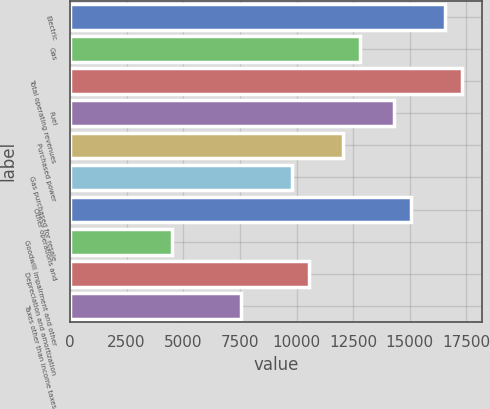Convert chart to OTSL. <chart><loc_0><loc_0><loc_500><loc_500><bar_chart><fcel>Electric<fcel>Gas<fcel>Total operating revenues<fcel>Fuel<fcel>Purchased power<fcel>Gas purchased for resale<fcel>Other operations and<fcel>Goodwill impairment and other<fcel>Depreciation and amortization<fcel>Taxes other than income taxes<nl><fcel>16566.3<fcel>12801.6<fcel>17319.3<fcel>14307.5<fcel>12048.6<fcel>9789.82<fcel>15060.4<fcel>4519.23<fcel>10542.8<fcel>7530.99<nl></chart> 